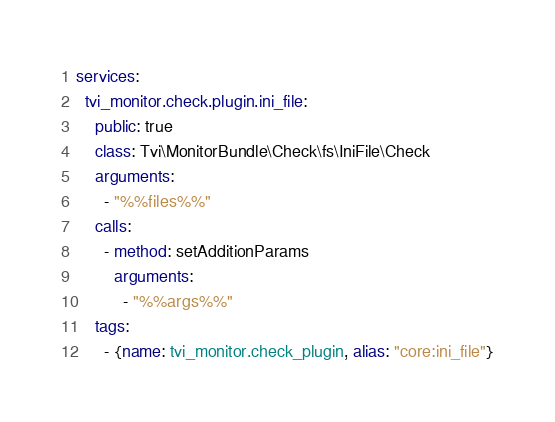<code> <loc_0><loc_0><loc_500><loc_500><_YAML_>services:
  tvi_monitor.check.plugin.ini_file:
    public: true
    class: Tvi\MonitorBundle\Check\fs\IniFile\Check
    arguments:
      - "%%files%%"
    calls:
      - method: setAdditionParams
        arguments:
          - "%%args%%"
    tags:
      - {name: tvi_monitor.check_plugin, alias: "core:ini_file"}
</code> 